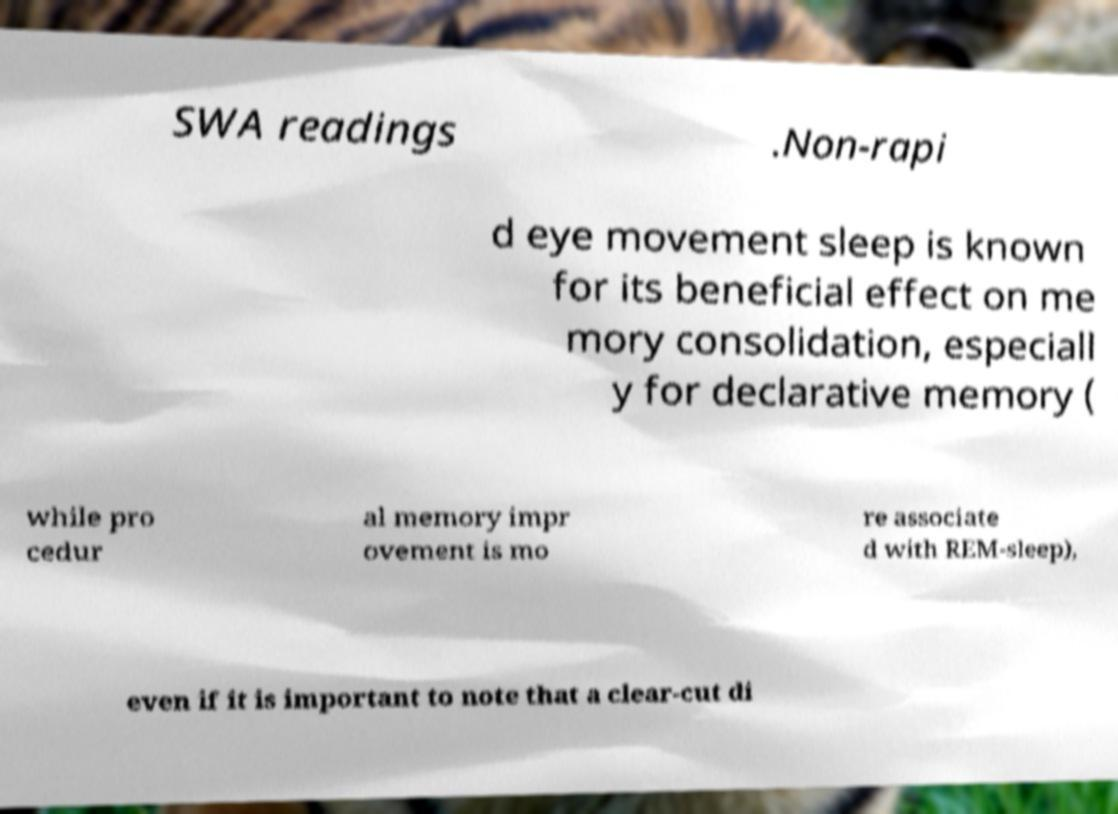Could you assist in decoding the text presented in this image and type it out clearly? SWA readings .Non-rapi d eye movement sleep is known for its beneficial effect on me mory consolidation, especiall y for declarative memory ( while pro cedur al memory impr ovement is mo re associate d with REM-sleep), even if it is important to note that a clear-cut di 